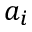Convert formula to latex. <formula><loc_0><loc_0><loc_500><loc_500>a _ { i }</formula> 